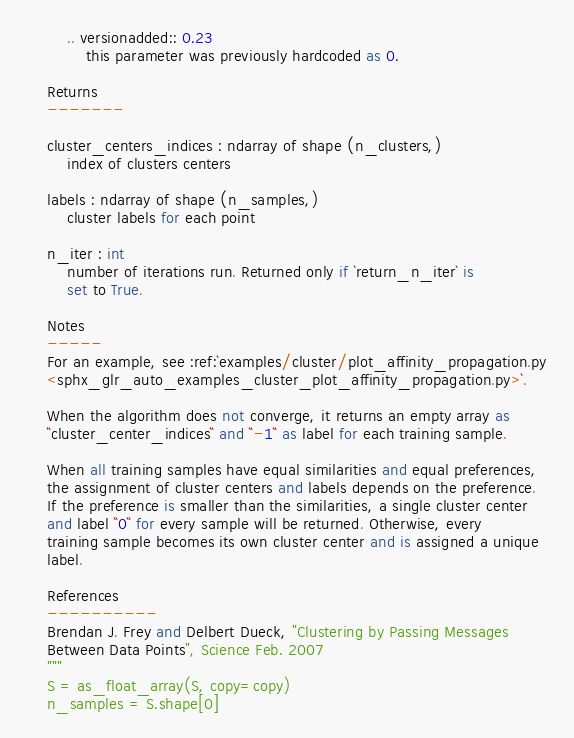<code> <loc_0><loc_0><loc_500><loc_500><_Python_>        .. versionadded:: 0.23
            this parameter was previously hardcoded as 0.

    Returns
    -------

    cluster_centers_indices : ndarray of shape (n_clusters,)
        index of clusters centers

    labels : ndarray of shape (n_samples,)
        cluster labels for each point

    n_iter : int
        number of iterations run. Returned only if `return_n_iter` is
        set to True.

    Notes
    -----
    For an example, see :ref:`examples/cluster/plot_affinity_propagation.py
    <sphx_glr_auto_examples_cluster_plot_affinity_propagation.py>`.

    When the algorithm does not converge, it returns an empty array as
    ``cluster_center_indices`` and ``-1`` as label for each training sample.

    When all training samples have equal similarities and equal preferences,
    the assignment of cluster centers and labels depends on the preference.
    If the preference is smaller than the similarities, a single cluster center
    and label ``0`` for every sample will be returned. Otherwise, every
    training sample becomes its own cluster center and is assigned a unique
    label.

    References
    ----------
    Brendan J. Frey and Delbert Dueck, "Clustering by Passing Messages
    Between Data Points", Science Feb. 2007
    """
    S = as_float_array(S, copy=copy)
    n_samples = S.shape[0]
</code> 